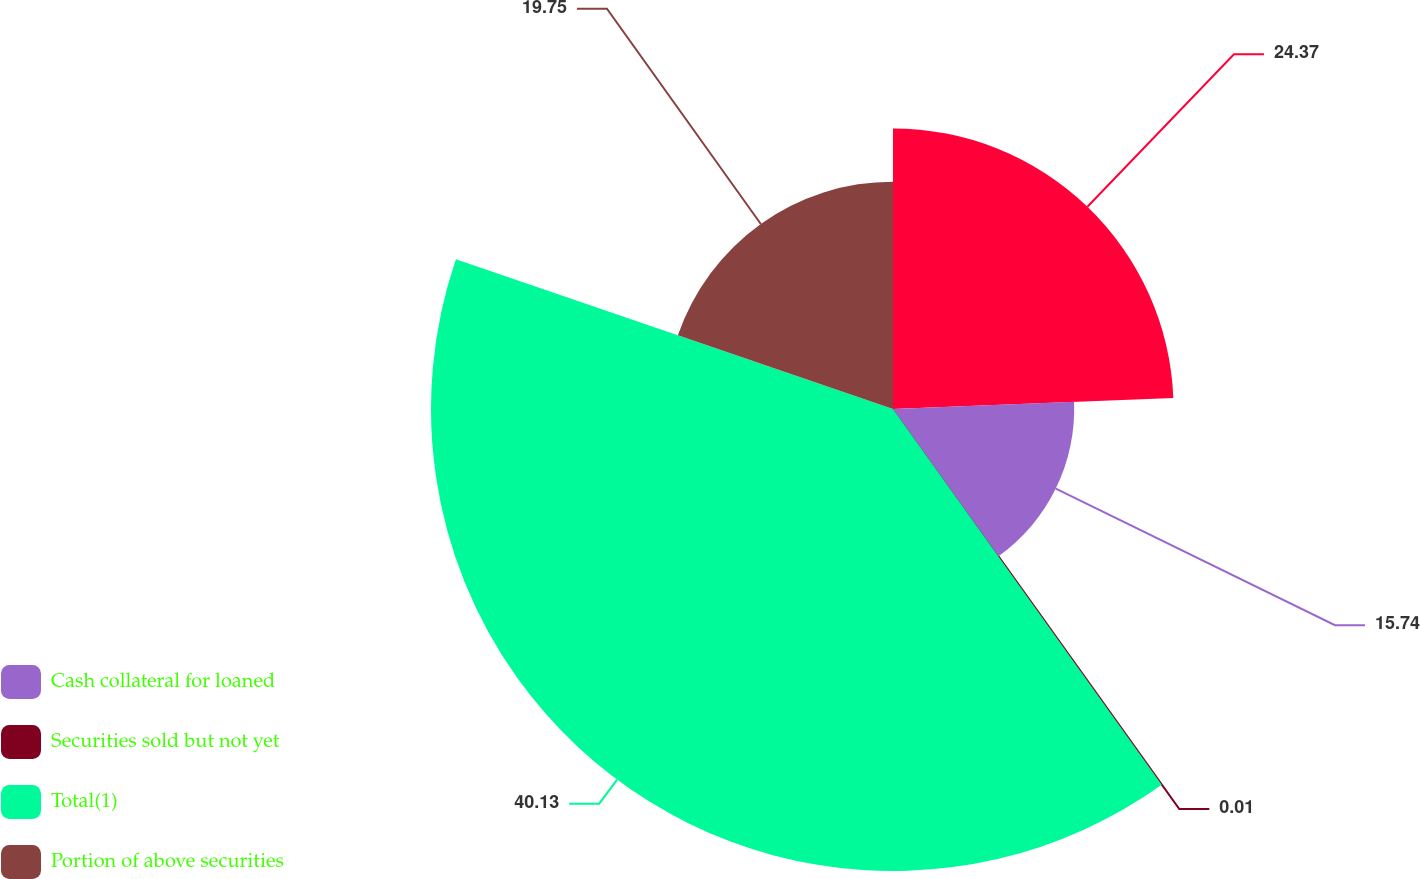Convert chart to OTSL. <chart><loc_0><loc_0><loc_500><loc_500><pie_chart><ecel><fcel>Cash collateral for loaned<fcel>Securities sold but not yet<fcel>Total(1)<fcel>Portion of above securities<nl><fcel>24.37%<fcel>15.74%<fcel>0.01%<fcel>40.13%<fcel>19.75%<nl></chart> 